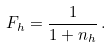Convert formula to latex. <formula><loc_0><loc_0><loc_500><loc_500>F _ { h } = \frac { 1 } { 1 + n _ { h } } \, .</formula> 